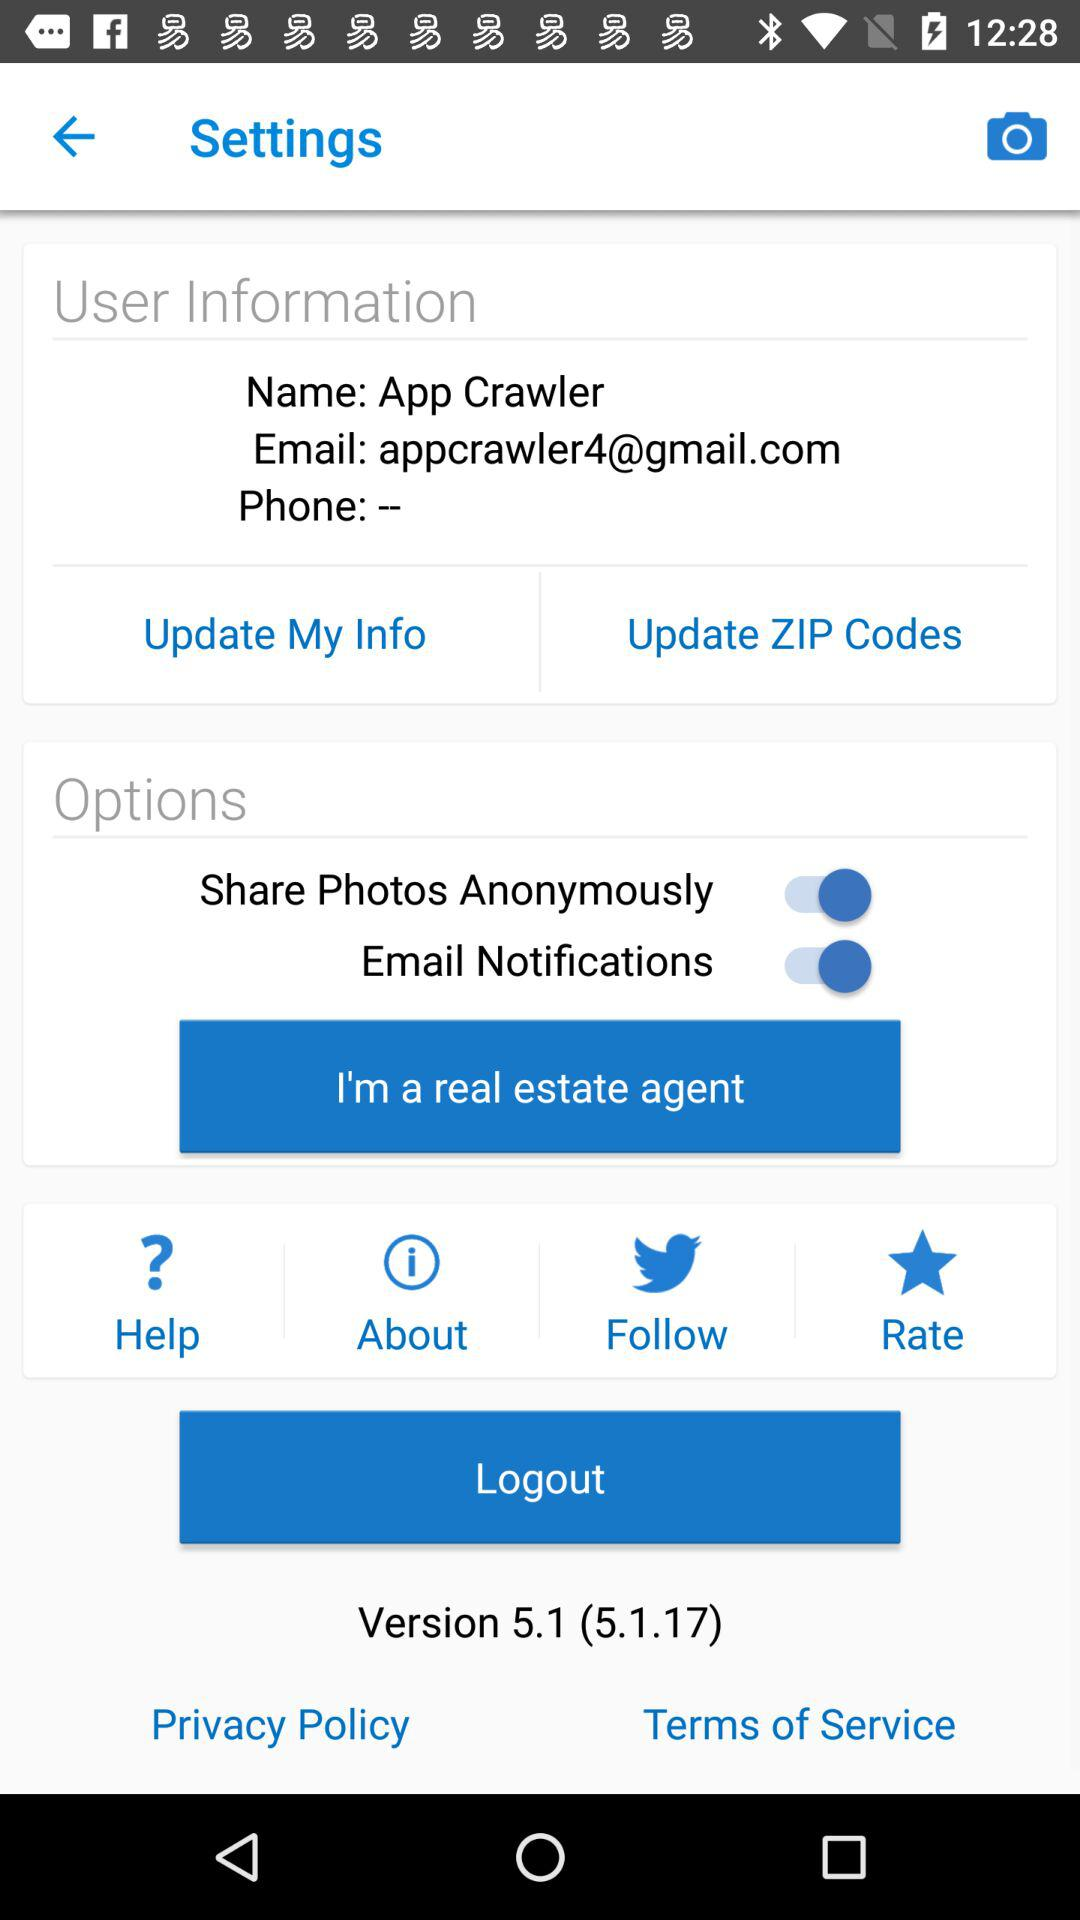What is the email address of the user? The email address of the user is appcrawler4@gmail.com. 